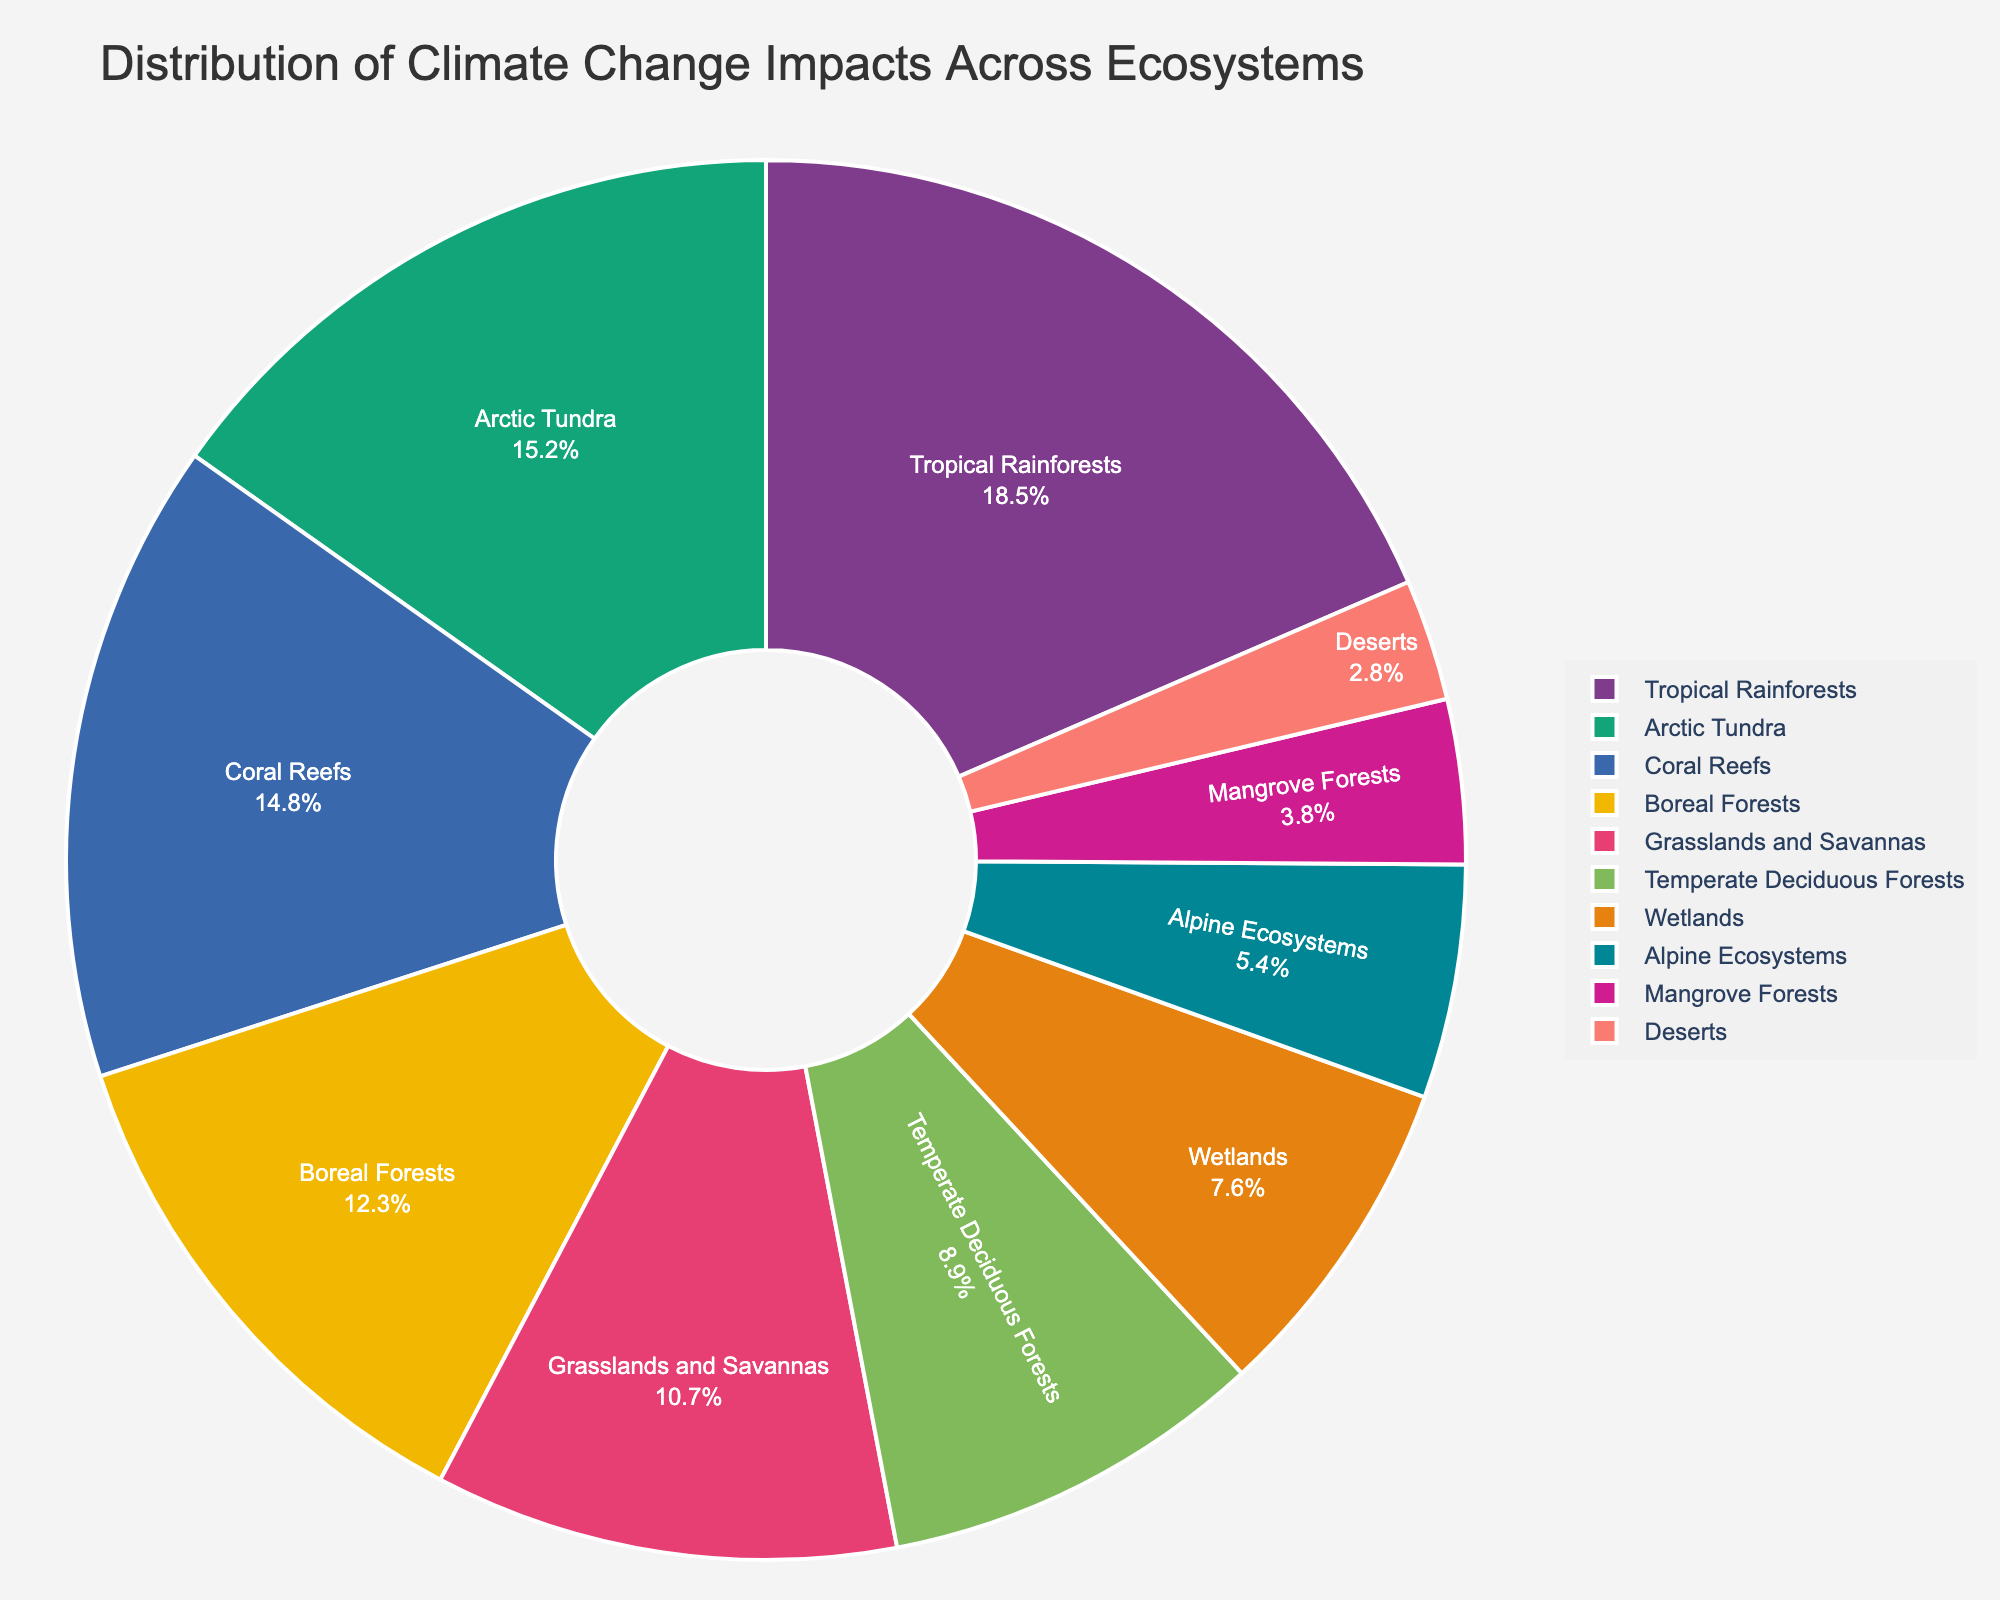What ecosystem has the highest impact percentage according to the pie chart? Look at the segment with the largest size in the pie chart. The title and labels make it clear that the Tropical Rainforests have the highest impact percentage.
Answer: Tropical Rainforests Which ecosystem has a lower impact percentage: Grasslands and Savannas or Temperate Deciduous Forests? Compare the size of the segments labeled “Grasslands and Savannas” and “Temperate Deciduous Forests.” The chart shows that Grasslands and Savannas have a higher percentage than Temperate Deciduous Forests.
Answer: Temperate Deciduous Forests What is the combined impact percentage of Arctic Tundra and Coral Reefs? Locate both Arctic Tundra and Coral Reefs on the pie chart. Add their impact percentages (15.2 + 14.8). Therefore, the combined impact is 30%.
Answer: 30% Among the ecosystems listed, which has the lowest impact percentage? Identify the smallest segment in the pie chart, which corresponds to Deserts.
Answer: Deserts How much greater is the impact percentage for Boreal Forests compared to Mangrove Forests? Locate both Boreal Forests and Mangrove Forests on the pie chart. Subtract the Mangrove Forests percentage from the Boreal Forests percentage (12.3 - 3.8). The difference is 8.5%.
Answer: 8.5% If the total impact percentages of Coral Reefs and Temperate Deciduous Forests are compared, which is higher and by how much? Compare the impact percentages of both ecosystems. Coral Reefs have 14.8% and Temperate Deciduous Forests have 8.9%. Subtract 8.9% from 14.8%. Therefore, Coral Reefs have a 5.9% higher impact.
Answer: Coral Reefs; 5.9% What is the combined impact percentage of the three ecosystems with the smallest values? Locate the three ecosystems with the smallest segments (Mangrove Forests, Alpine Ecosystems, Deserts). Add their impact percentages (3.8 + 5.4 + 2.8). Therefore, the combined impact is 12%.
Answer: 12% How much smaller is the impact percentage of Wetlands compared to Tropical Rainforests? Locate both Wetlands and Tropical Rainforests on the pie chart. Subtract the Wetlands percentage from the Tropical Rainforests percentage (18.5 - 7.6). The difference is 10.9%.
Answer: 10.9% 